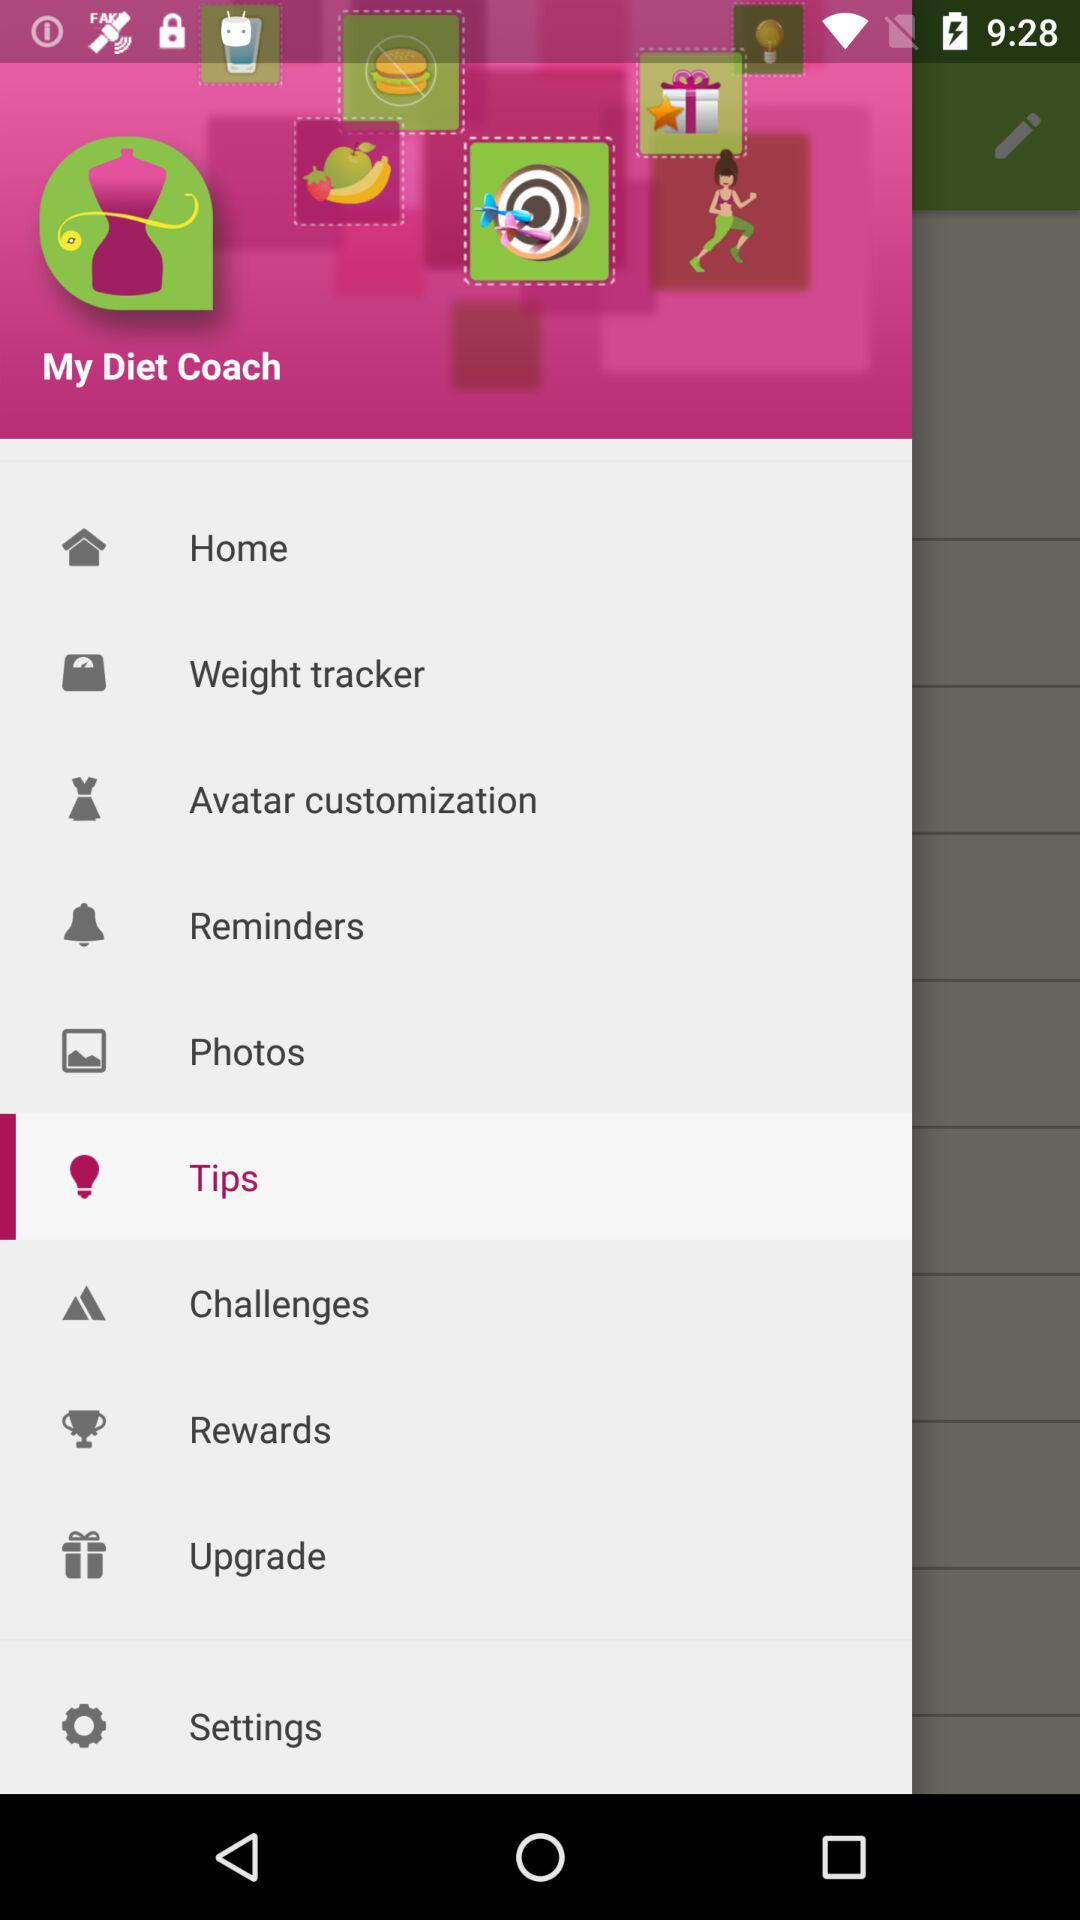Which item is selected in the menu? The selected item is "Tips". 